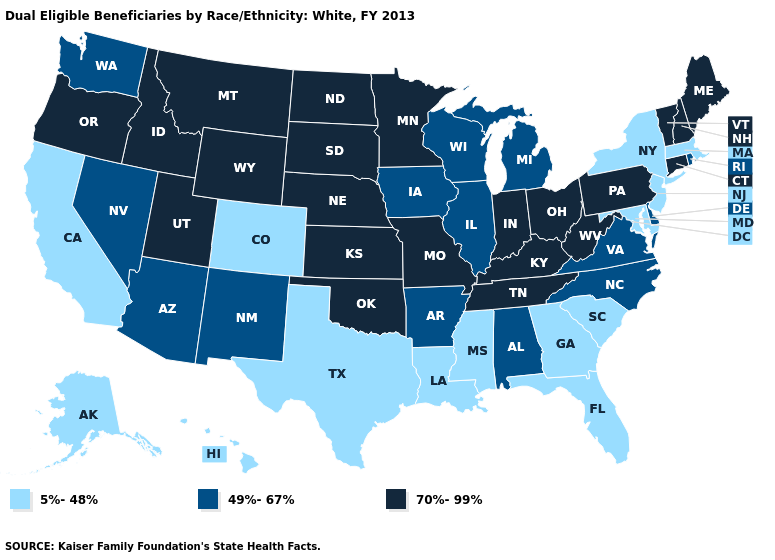Among the states that border Virginia , which have the highest value?
Answer briefly. Kentucky, Tennessee, West Virginia. What is the value of Massachusetts?
Write a very short answer. 5%-48%. Name the states that have a value in the range 70%-99%?
Give a very brief answer. Connecticut, Idaho, Indiana, Kansas, Kentucky, Maine, Minnesota, Missouri, Montana, Nebraska, New Hampshire, North Dakota, Ohio, Oklahoma, Oregon, Pennsylvania, South Dakota, Tennessee, Utah, Vermont, West Virginia, Wyoming. Does the first symbol in the legend represent the smallest category?
Answer briefly. Yes. Which states have the lowest value in the USA?
Answer briefly. Alaska, California, Colorado, Florida, Georgia, Hawaii, Louisiana, Maryland, Massachusetts, Mississippi, New Jersey, New York, South Carolina, Texas. What is the lowest value in the Northeast?
Concise answer only. 5%-48%. Does Delaware have a lower value than Wisconsin?
Concise answer only. No. Which states have the highest value in the USA?
Give a very brief answer. Connecticut, Idaho, Indiana, Kansas, Kentucky, Maine, Minnesota, Missouri, Montana, Nebraska, New Hampshire, North Dakota, Ohio, Oklahoma, Oregon, Pennsylvania, South Dakota, Tennessee, Utah, Vermont, West Virginia, Wyoming. Among the states that border Colorado , which have the lowest value?
Quick response, please. Arizona, New Mexico. Does Wisconsin have the lowest value in the USA?
Concise answer only. No. Does Oregon have a higher value than Florida?
Be succinct. Yes. What is the value of Montana?
Short answer required. 70%-99%. Name the states that have a value in the range 70%-99%?
Keep it brief. Connecticut, Idaho, Indiana, Kansas, Kentucky, Maine, Minnesota, Missouri, Montana, Nebraska, New Hampshire, North Dakota, Ohio, Oklahoma, Oregon, Pennsylvania, South Dakota, Tennessee, Utah, Vermont, West Virginia, Wyoming. Which states hav the highest value in the Northeast?
Give a very brief answer. Connecticut, Maine, New Hampshire, Pennsylvania, Vermont. 